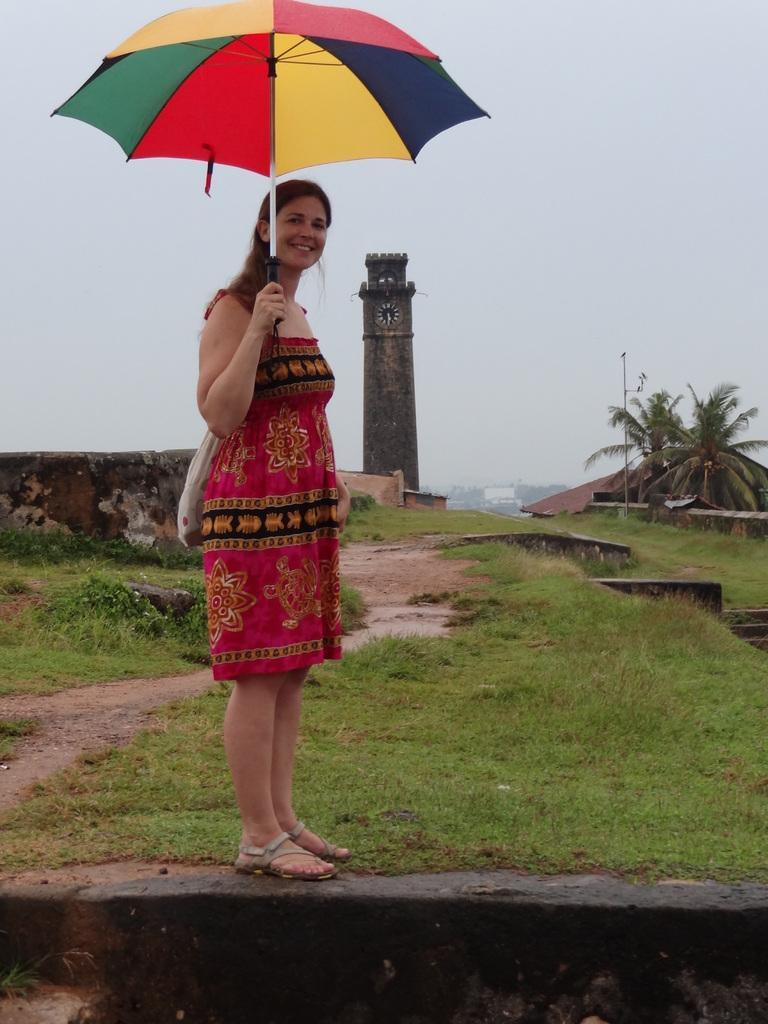Please provide a concise description of this image. In the picture we can see a woman standing near the grass surface on the wall and holding an umbrella and in the background, we can see a clock tower and besides it we can see some trees and behind it we can see a sky. 